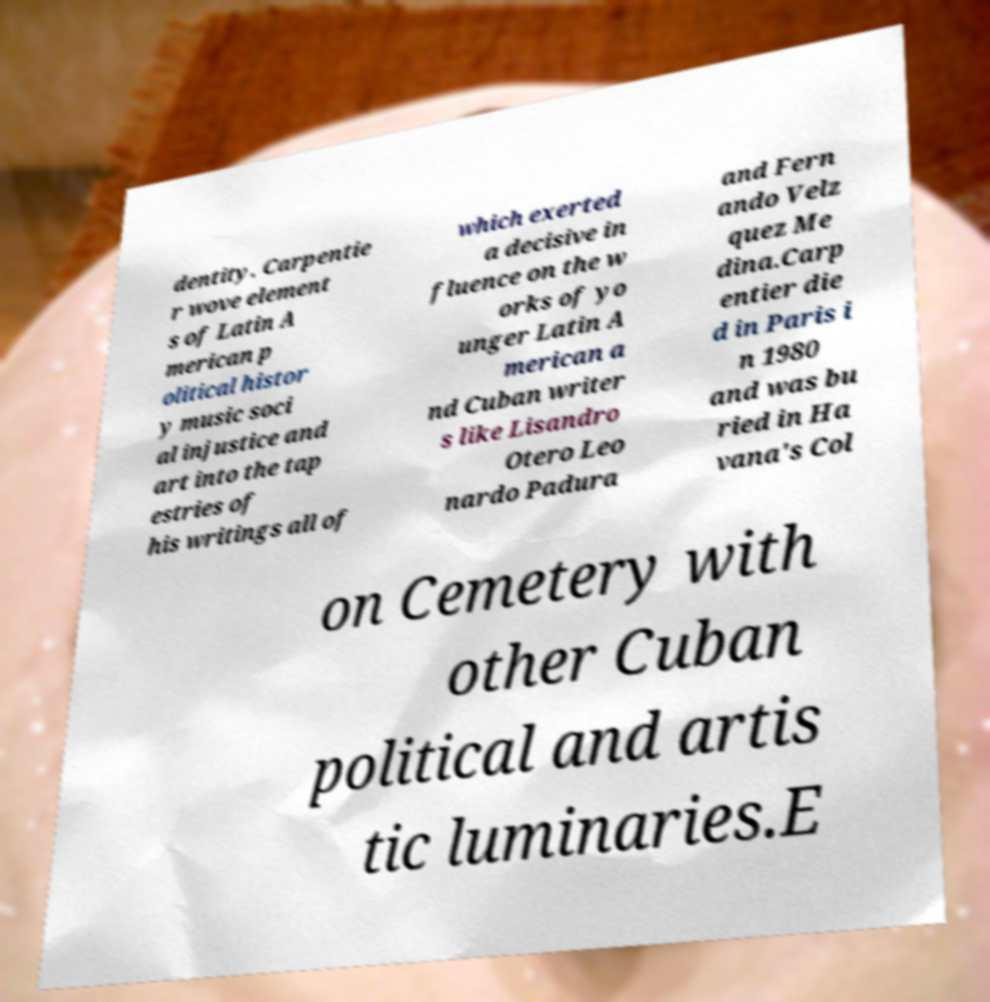Please read and relay the text visible in this image. What does it say? dentity. Carpentie r wove element s of Latin A merican p olitical histor y music soci al injustice and art into the tap estries of his writings all of which exerted a decisive in fluence on the w orks of yo unger Latin A merican a nd Cuban writer s like Lisandro Otero Leo nardo Padura and Fern ando Velz quez Me dina.Carp entier die d in Paris i n 1980 and was bu ried in Ha vana's Col on Cemetery with other Cuban political and artis tic luminaries.E 